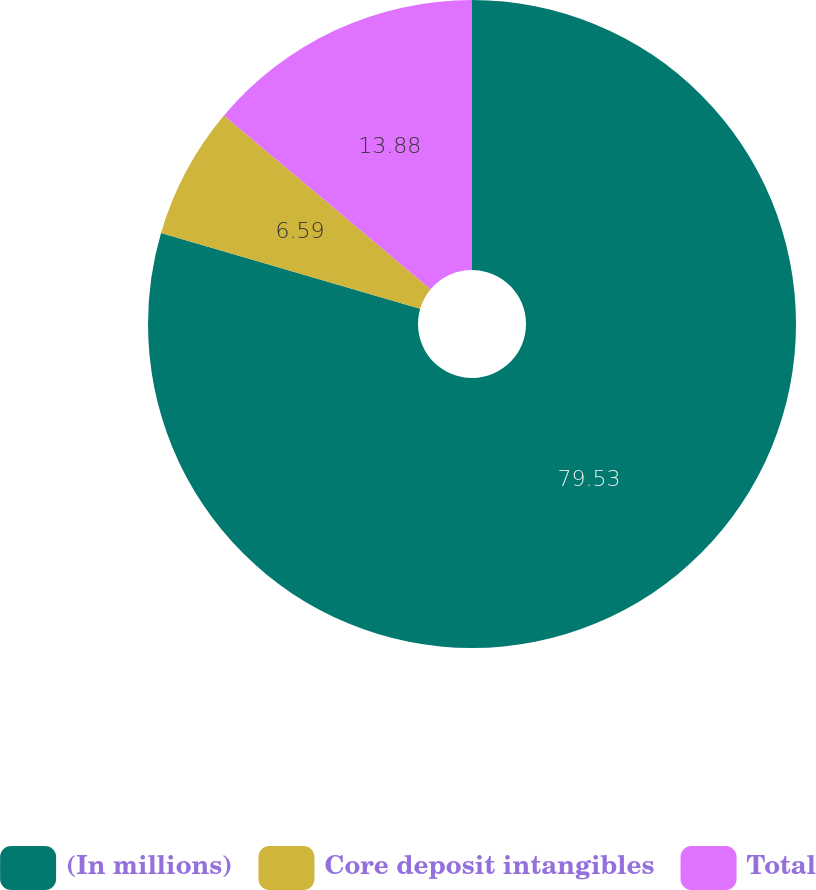Convert chart. <chart><loc_0><loc_0><loc_500><loc_500><pie_chart><fcel>(In millions)<fcel>Core deposit intangibles<fcel>Total<nl><fcel>79.53%<fcel>6.59%<fcel>13.88%<nl></chart> 